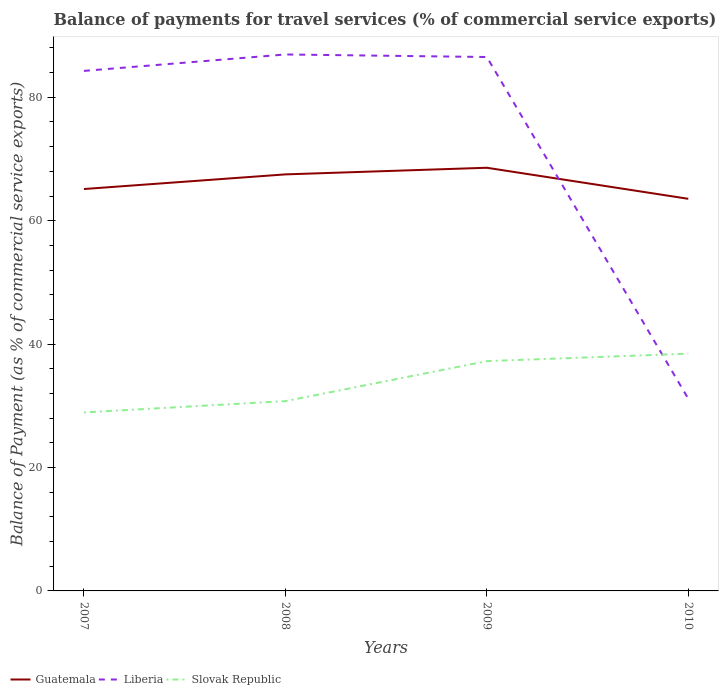How many different coloured lines are there?
Your response must be concise. 3. Across all years, what is the maximum balance of payments for travel services in Liberia?
Provide a succinct answer. 31.15. What is the total balance of payments for travel services in Slovak Republic in the graph?
Provide a succinct answer. -1.21. What is the difference between the highest and the second highest balance of payments for travel services in Liberia?
Make the answer very short. 55.79. What is the difference between the highest and the lowest balance of payments for travel services in Guatemala?
Your answer should be very brief. 2. Is the balance of payments for travel services in Slovak Republic strictly greater than the balance of payments for travel services in Guatemala over the years?
Give a very brief answer. Yes. How many lines are there?
Provide a succinct answer. 3. How many years are there in the graph?
Offer a terse response. 4. Are the values on the major ticks of Y-axis written in scientific E-notation?
Provide a succinct answer. No. Does the graph contain any zero values?
Offer a terse response. No. Does the graph contain grids?
Ensure brevity in your answer.  No. How are the legend labels stacked?
Your answer should be compact. Horizontal. What is the title of the graph?
Your answer should be very brief. Balance of payments for travel services (% of commercial service exports). Does "Colombia" appear as one of the legend labels in the graph?
Your response must be concise. No. What is the label or title of the X-axis?
Provide a succinct answer. Years. What is the label or title of the Y-axis?
Give a very brief answer. Balance of Payment (as % of commercial service exports). What is the Balance of Payment (as % of commercial service exports) in Guatemala in 2007?
Give a very brief answer. 65.13. What is the Balance of Payment (as % of commercial service exports) of Liberia in 2007?
Keep it short and to the point. 84.28. What is the Balance of Payment (as % of commercial service exports) in Slovak Republic in 2007?
Give a very brief answer. 28.93. What is the Balance of Payment (as % of commercial service exports) of Guatemala in 2008?
Make the answer very short. 67.51. What is the Balance of Payment (as % of commercial service exports) in Liberia in 2008?
Make the answer very short. 86.94. What is the Balance of Payment (as % of commercial service exports) of Slovak Republic in 2008?
Give a very brief answer. 30.76. What is the Balance of Payment (as % of commercial service exports) in Guatemala in 2009?
Keep it short and to the point. 68.58. What is the Balance of Payment (as % of commercial service exports) of Liberia in 2009?
Your response must be concise. 86.53. What is the Balance of Payment (as % of commercial service exports) of Slovak Republic in 2009?
Give a very brief answer. 37.24. What is the Balance of Payment (as % of commercial service exports) of Guatemala in 2010?
Offer a very short reply. 63.55. What is the Balance of Payment (as % of commercial service exports) of Liberia in 2010?
Your answer should be very brief. 31.15. What is the Balance of Payment (as % of commercial service exports) of Slovak Republic in 2010?
Your answer should be very brief. 38.45. Across all years, what is the maximum Balance of Payment (as % of commercial service exports) of Guatemala?
Ensure brevity in your answer.  68.58. Across all years, what is the maximum Balance of Payment (as % of commercial service exports) of Liberia?
Offer a terse response. 86.94. Across all years, what is the maximum Balance of Payment (as % of commercial service exports) of Slovak Republic?
Give a very brief answer. 38.45. Across all years, what is the minimum Balance of Payment (as % of commercial service exports) in Guatemala?
Your answer should be compact. 63.55. Across all years, what is the minimum Balance of Payment (as % of commercial service exports) in Liberia?
Provide a succinct answer. 31.15. Across all years, what is the minimum Balance of Payment (as % of commercial service exports) of Slovak Republic?
Provide a short and direct response. 28.93. What is the total Balance of Payment (as % of commercial service exports) in Guatemala in the graph?
Ensure brevity in your answer.  264.77. What is the total Balance of Payment (as % of commercial service exports) of Liberia in the graph?
Provide a short and direct response. 288.89. What is the total Balance of Payment (as % of commercial service exports) in Slovak Republic in the graph?
Your answer should be compact. 135.38. What is the difference between the Balance of Payment (as % of commercial service exports) in Guatemala in 2007 and that in 2008?
Offer a very short reply. -2.37. What is the difference between the Balance of Payment (as % of commercial service exports) of Liberia in 2007 and that in 2008?
Provide a succinct answer. -2.66. What is the difference between the Balance of Payment (as % of commercial service exports) in Slovak Republic in 2007 and that in 2008?
Your response must be concise. -1.83. What is the difference between the Balance of Payment (as % of commercial service exports) in Guatemala in 2007 and that in 2009?
Offer a terse response. -3.45. What is the difference between the Balance of Payment (as % of commercial service exports) of Liberia in 2007 and that in 2009?
Give a very brief answer. -2.25. What is the difference between the Balance of Payment (as % of commercial service exports) in Slovak Republic in 2007 and that in 2009?
Provide a succinct answer. -8.31. What is the difference between the Balance of Payment (as % of commercial service exports) in Guatemala in 2007 and that in 2010?
Offer a very short reply. 1.59. What is the difference between the Balance of Payment (as % of commercial service exports) in Liberia in 2007 and that in 2010?
Make the answer very short. 53.13. What is the difference between the Balance of Payment (as % of commercial service exports) in Slovak Republic in 2007 and that in 2010?
Provide a succinct answer. -9.53. What is the difference between the Balance of Payment (as % of commercial service exports) of Guatemala in 2008 and that in 2009?
Provide a succinct answer. -1.07. What is the difference between the Balance of Payment (as % of commercial service exports) of Liberia in 2008 and that in 2009?
Offer a very short reply. 0.41. What is the difference between the Balance of Payment (as % of commercial service exports) in Slovak Republic in 2008 and that in 2009?
Ensure brevity in your answer.  -6.48. What is the difference between the Balance of Payment (as % of commercial service exports) in Guatemala in 2008 and that in 2010?
Your answer should be very brief. 3.96. What is the difference between the Balance of Payment (as % of commercial service exports) of Liberia in 2008 and that in 2010?
Your answer should be compact. 55.79. What is the difference between the Balance of Payment (as % of commercial service exports) of Slovak Republic in 2008 and that in 2010?
Keep it short and to the point. -7.69. What is the difference between the Balance of Payment (as % of commercial service exports) in Guatemala in 2009 and that in 2010?
Your answer should be compact. 5.03. What is the difference between the Balance of Payment (as % of commercial service exports) of Liberia in 2009 and that in 2010?
Keep it short and to the point. 55.38. What is the difference between the Balance of Payment (as % of commercial service exports) of Slovak Republic in 2009 and that in 2010?
Offer a very short reply. -1.21. What is the difference between the Balance of Payment (as % of commercial service exports) of Guatemala in 2007 and the Balance of Payment (as % of commercial service exports) of Liberia in 2008?
Give a very brief answer. -21.81. What is the difference between the Balance of Payment (as % of commercial service exports) of Guatemala in 2007 and the Balance of Payment (as % of commercial service exports) of Slovak Republic in 2008?
Keep it short and to the point. 34.37. What is the difference between the Balance of Payment (as % of commercial service exports) of Liberia in 2007 and the Balance of Payment (as % of commercial service exports) of Slovak Republic in 2008?
Provide a succinct answer. 53.52. What is the difference between the Balance of Payment (as % of commercial service exports) of Guatemala in 2007 and the Balance of Payment (as % of commercial service exports) of Liberia in 2009?
Provide a succinct answer. -21.39. What is the difference between the Balance of Payment (as % of commercial service exports) in Guatemala in 2007 and the Balance of Payment (as % of commercial service exports) in Slovak Republic in 2009?
Provide a succinct answer. 27.89. What is the difference between the Balance of Payment (as % of commercial service exports) in Liberia in 2007 and the Balance of Payment (as % of commercial service exports) in Slovak Republic in 2009?
Keep it short and to the point. 47.04. What is the difference between the Balance of Payment (as % of commercial service exports) in Guatemala in 2007 and the Balance of Payment (as % of commercial service exports) in Liberia in 2010?
Make the answer very short. 33.98. What is the difference between the Balance of Payment (as % of commercial service exports) in Guatemala in 2007 and the Balance of Payment (as % of commercial service exports) in Slovak Republic in 2010?
Offer a very short reply. 26.68. What is the difference between the Balance of Payment (as % of commercial service exports) of Liberia in 2007 and the Balance of Payment (as % of commercial service exports) of Slovak Republic in 2010?
Provide a short and direct response. 45.83. What is the difference between the Balance of Payment (as % of commercial service exports) in Guatemala in 2008 and the Balance of Payment (as % of commercial service exports) in Liberia in 2009?
Provide a succinct answer. -19.02. What is the difference between the Balance of Payment (as % of commercial service exports) of Guatemala in 2008 and the Balance of Payment (as % of commercial service exports) of Slovak Republic in 2009?
Keep it short and to the point. 30.27. What is the difference between the Balance of Payment (as % of commercial service exports) in Liberia in 2008 and the Balance of Payment (as % of commercial service exports) in Slovak Republic in 2009?
Keep it short and to the point. 49.7. What is the difference between the Balance of Payment (as % of commercial service exports) of Guatemala in 2008 and the Balance of Payment (as % of commercial service exports) of Liberia in 2010?
Offer a very short reply. 36.36. What is the difference between the Balance of Payment (as % of commercial service exports) in Guatemala in 2008 and the Balance of Payment (as % of commercial service exports) in Slovak Republic in 2010?
Your response must be concise. 29.05. What is the difference between the Balance of Payment (as % of commercial service exports) of Liberia in 2008 and the Balance of Payment (as % of commercial service exports) of Slovak Republic in 2010?
Provide a succinct answer. 48.49. What is the difference between the Balance of Payment (as % of commercial service exports) of Guatemala in 2009 and the Balance of Payment (as % of commercial service exports) of Liberia in 2010?
Ensure brevity in your answer.  37.43. What is the difference between the Balance of Payment (as % of commercial service exports) of Guatemala in 2009 and the Balance of Payment (as % of commercial service exports) of Slovak Republic in 2010?
Keep it short and to the point. 30.13. What is the difference between the Balance of Payment (as % of commercial service exports) in Liberia in 2009 and the Balance of Payment (as % of commercial service exports) in Slovak Republic in 2010?
Ensure brevity in your answer.  48.07. What is the average Balance of Payment (as % of commercial service exports) in Guatemala per year?
Provide a short and direct response. 66.19. What is the average Balance of Payment (as % of commercial service exports) in Liberia per year?
Give a very brief answer. 72.22. What is the average Balance of Payment (as % of commercial service exports) in Slovak Republic per year?
Your answer should be compact. 33.84. In the year 2007, what is the difference between the Balance of Payment (as % of commercial service exports) in Guatemala and Balance of Payment (as % of commercial service exports) in Liberia?
Offer a terse response. -19.14. In the year 2007, what is the difference between the Balance of Payment (as % of commercial service exports) of Guatemala and Balance of Payment (as % of commercial service exports) of Slovak Republic?
Your response must be concise. 36.21. In the year 2007, what is the difference between the Balance of Payment (as % of commercial service exports) of Liberia and Balance of Payment (as % of commercial service exports) of Slovak Republic?
Keep it short and to the point. 55.35. In the year 2008, what is the difference between the Balance of Payment (as % of commercial service exports) of Guatemala and Balance of Payment (as % of commercial service exports) of Liberia?
Provide a short and direct response. -19.43. In the year 2008, what is the difference between the Balance of Payment (as % of commercial service exports) of Guatemala and Balance of Payment (as % of commercial service exports) of Slovak Republic?
Ensure brevity in your answer.  36.75. In the year 2008, what is the difference between the Balance of Payment (as % of commercial service exports) in Liberia and Balance of Payment (as % of commercial service exports) in Slovak Republic?
Offer a terse response. 56.18. In the year 2009, what is the difference between the Balance of Payment (as % of commercial service exports) of Guatemala and Balance of Payment (as % of commercial service exports) of Liberia?
Ensure brevity in your answer.  -17.95. In the year 2009, what is the difference between the Balance of Payment (as % of commercial service exports) of Guatemala and Balance of Payment (as % of commercial service exports) of Slovak Republic?
Your answer should be very brief. 31.34. In the year 2009, what is the difference between the Balance of Payment (as % of commercial service exports) of Liberia and Balance of Payment (as % of commercial service exports) of Slovak Republic?
Offer a very short reply. 49.29. In the year 2010, what is the difference between the Balance of Payment (as % of commercial service exports) of Guatemala and Balance of Payment (as % of commercial service exports) of Liberia?
Provide a short and direct response. 32.4. In the year 2010, what is the difference between the Balance of Payment (as % of commercial service exports) in Guatemala and Balance of Payment (as % of commercial service exports) in Slovak Republic?
Give a very brief answer. 25.1. In the year 2010, what is the difference between the Balance of Payment (as % of commercial service exports) of Liberia and Balance of Payment (as % of commercial service exports) of Slovak Republic?
Provide a succinct answer. -7.3. What is the ratio of the Balance of Payment (as % of commercial service exports) of Guatemala in 2007 to that in 2008?
Make the answer very short. 0.96. What is the ratio of the Balance of Payment (as % of commercial service exports) in Liberia in 2007 to that in 2008?
Provide a succinct answer. 0.97. What is the ratio of the Balance of Payment (as % of commercial service exports) in Slovak Republic in 2007 to that in 2008?
Give a very brief answer. 0.94. What is the ratio of the Balance of Payment (as % of commercial service exports) of Guatemala in 2007 to that in 2009?
Your response must be concise. 0.95. What is the ratio of the Balance of Payment (as % of commercial service exports) in Slovak Republic in 2007 to that in 2009?
Give a very brief answer. 0.78. What is the ratio of the Balance of Payment (as % of commercial service exports) in Guatemala in 2007 to that in 2010?
Keep it short and to the point. 1.02. What is the ratio of the Balance of Payment (as % of commercial service exports) in Liberia in 2007 to that in 2010?
Provide a succinct answer. 2.71. What is the ratio of the Balance of Payment (as % of commercial service exports) in Slovak Republic in 2007 to that in 2010?
Offer a very short reply. 0.75. What is the ratio of the Balance of Payment (as % of commercial service exports) of Guatemala in 2008 to that in 2009?
Provide a short and direct response. 0.98. What is the ratio of the Balance of Payment (as % of commercial service exports) of Liberia in 2008 to that in 2009?
Offer a terse response. 1. What is the ratio of the Balance of Payment (as % of commercial service exports) in Slovak Republic in 2008 to that in 2009?
Keep it short and to the point. 0.83. What is the ratio of the Balance of Payment (as % of commercial service exports) of Guatemala in 2008 to that in 2010?
Offer a very short reply. 1.06. What is the ratio of the Balance of Payment (as % of commercial service exports) of Liberia in 2008 to that in 2010?
Give a very brief answer. 2.79. What is the ratio of the Balance of Payment (as % of commercial service exports) of Slovak Republic in 2008 to that in 2010?
Make the answer very short. 0.8. What is the ratio of the Balance of Payment (as % of commercial service exports) in Guatemala in 2009 to that in 2010?
Offer a very short reply. 1.08. What is the ratio of the Balance of Payment (as % of commercial service exports) of Liberia in 2009 to that in 2010?
Your response must be concise. 2.78. What is the ratio of the Balance of Payment (as % of commercial service exports) in Slovak Republic in 2009 to that in 2010?
Give a very brief answer. 0.97. What is the difference between the highest and the second highest Balance of Payment (as % of commercial service exports) of Guatemala?
Make the answer very short. 1.07. What is the difference between the highest and the second highest Balance of Payment (as % of commercial service exports) of Liberia?
Offer a terse response. 0.41. What is the difference between the highest and the second highest Balance of Payment (as % of commercial service exports) in Slovak Republic?
Make the answer very short. 1.21. What is the difference between the highest and the lowest Balance of Payment (as % of commercial service exports) in Guatemala?
Provide a short and direct response. 5.03. What is the difference between the highest and the lowest Balance of Payment (as % of commercial service exports) in Liberia?
Provide a succinct answer. 55.79. What is the difference between the highest and the lowest Balance of Payment (as % of commercial service exports) in Slovak Republic?
Provide a short and direct response. 9.53. 